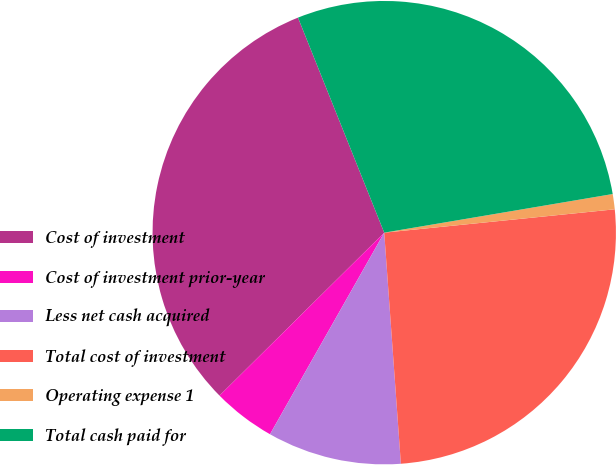Convert chart. <chart><loc_0><loc_0><loc_500><loc_500><pie_chart><fcel>Cost of investment<fcel>Cost of investment prior-year<fcel>Less net cash acquired<fcel>Total cost of investment<fcel>Operating expense 1<fcel>Total cash paid for<nl><fcel>31.34%<fcel>4.38%<fcel>9.35%<fcel>25.46%<fcel>1.06%<fcel>28.4%<nl></chart> 